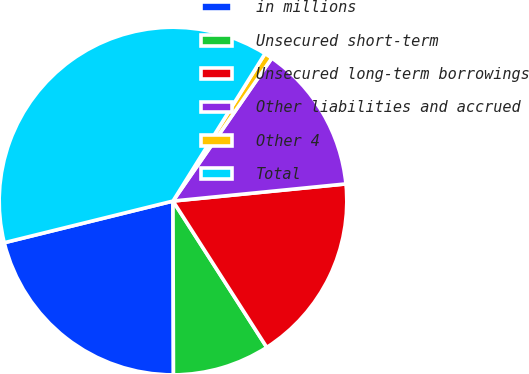Convert chart to OTSL. <chart><loc_0><loc_0><loc_500><loc_500><pie_chart><fcel>in millions<fcel>Unsecured short-term<fcel>Unsecured long-term borrowings<fcel>Other liabilities and accrued<fcel>Other 4<fcel>Total<nl><fcel>21.19%<fcel>9.03%<fcel>17.5%<fcel>13.8%<fcel>0.75%<fcel>37.73%<nl></chart> 